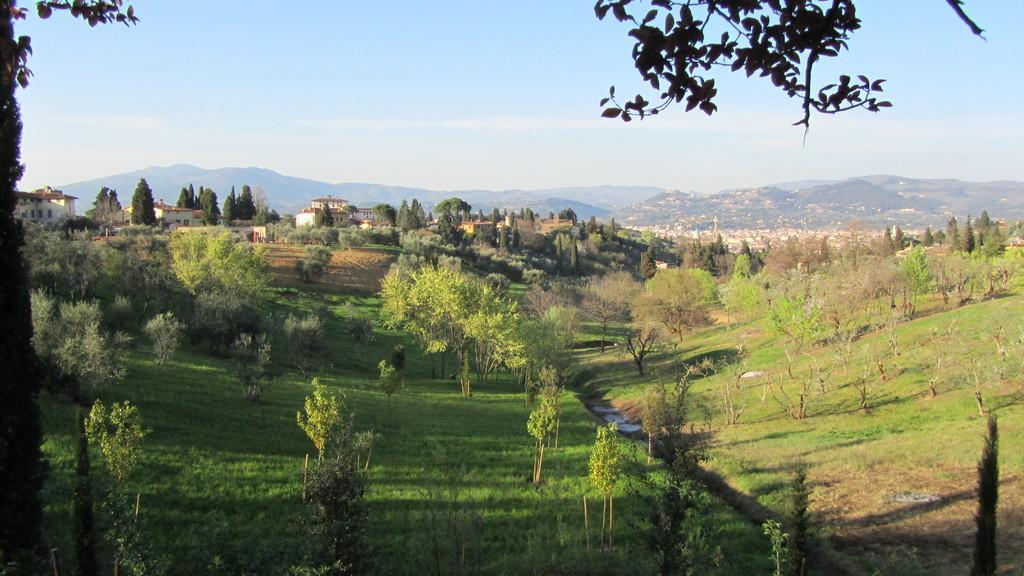How would you summarize this image in a sentence or two? This is the beautiful picture of a location. This is grass and these are the trees. And in the background we can see some houses. And this is the mountain and there is a sky. 